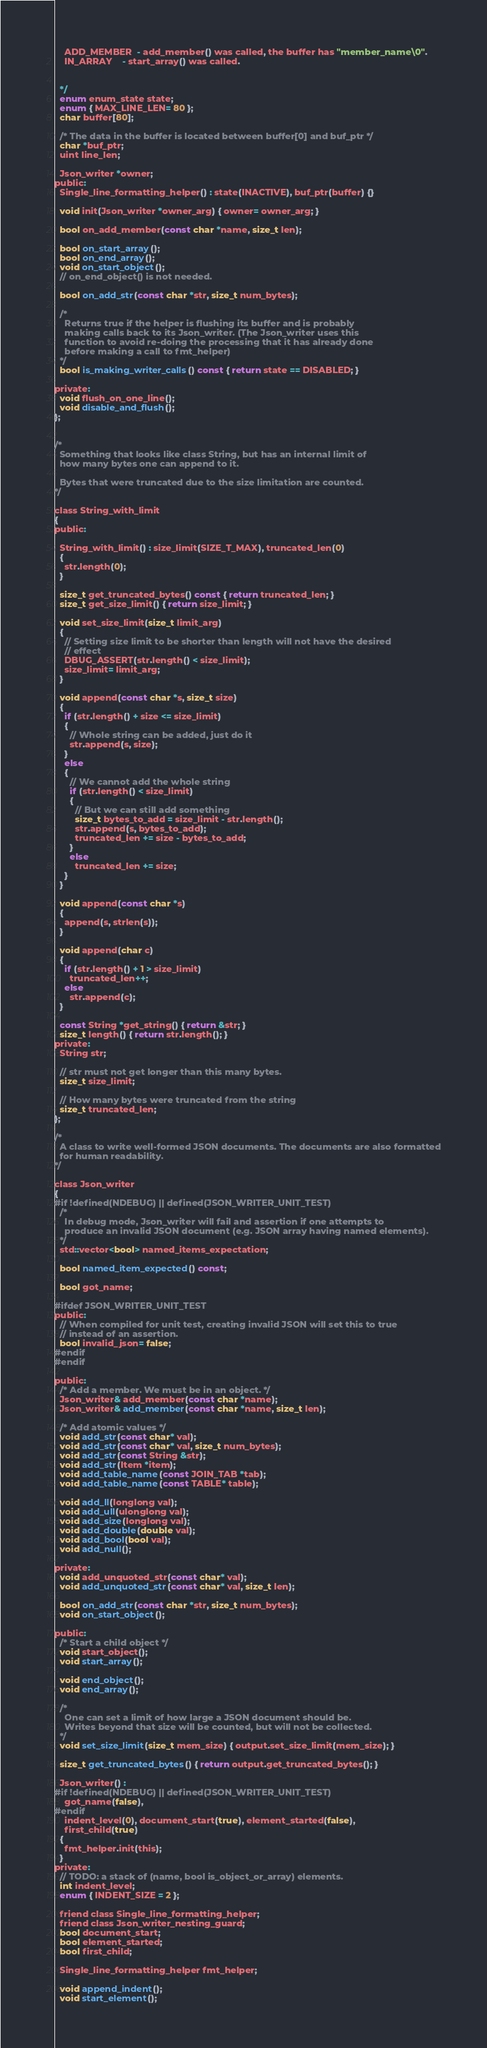<code> <loc_0><loc_0><loc_500><loc_500><_C_>    ADD_MEMBER  - add_member() was called, the buffer has "member_name\0".
    IN_ARRAY    - start_array() was called.


  */
  enum enum_state state;
  enum { MAX_LINE_LEN= 80 };
  char buffer[80];

  /* The data in the buffer is located between buffer[0] and buf_ptr */
  char *buf_ptr;
  uint line_len;

  Json_writer *owner;
public:
  Single_line_formatting_helper() : state(INACTIVE), buf_ptr(buffer) {}

  void init(Json_writer *owner_arg) { owner= owner_arg; }

  bool on_add_member(const char *name, size_t len);

  bool on_start_array();
  bool on_end_array();
  void on_start_object();
  // on_end_object() is not needed.

  bool on_add_str(const char *str, size_t num_bytes);

  /*
    Returns true if the helper is flushing its buffer and is probably
    making calls back to its Json_writer. (The Json_writer uses this
    function to avoid re-doing the processing that it has already done
    before making a call to fmt_helper)
  */
  bool is_making_writer_calls() const { return state == DISABLED; }

private:
  void flush_on_one_line();
  void disable_and_flush();
};


/*
  Something that looks like class String, but has an internal limit of
  how many bytes one can append to it.

  Bytes that were truncated due to the size limitation are counted.
*/

class String_with_limit
{
public:

  String_with_limit() : size_limit(SIZE_T_MAX), truncated_len(0)
  {
    str.length(0);
  }

  size_t get_truncated_bytes() const { return truncated_len; }
  size_t get_size_limit() { return size_limit; }

  void set_size_limit(size_t limit_arg)
  {
    // Setting size limit to be shorter than length will not have the desired
    // effect
    DBUG_ASSERT(str.length() < size_limit);
    size_limit= limit_arg;
  }

  void append(const char *s, size_t size)
  {
    if (str.length() + size <= size_limit)
    {
      // Whole string can be added, just do it
      str.append(s, size);
    }
    else
    {
      // We cannot add the whole string
      if (str.length() < size_limit)
      {
        // But we can still add something
        size_t bytes_to_add = size_limit - str.length();
        str.append(s, bytes_to_add);
        truncated_len += size - bytes_to_add;
      }
      else
        truncated_len += size;
    }
  }

  void append(const char *s)
  {
    append(s, strlen(s));
  }

  void append(char c)
  {
    if (str.length() + 1 > size_limit)
      truncated_len++;
    else
      str.append(c);
  }

  const String *get_string() { return &str; }
  size_t length() { return str.length(); }
private:
  String str;

  // str must not get longer than this many bytes.
  size_t size_limit;

  // How many bytes were truncated from the string
  size_t truncated_len;
};

/*
  A class to write well-formed JSON documents. The documents are also formatted
  for human readability.
*/

class Json_writer
{
#if !defined(NDEBUG) || defined(JSON_WRITER_UNIT_TEST)
  /*
    In debug mode, Json_writer will fail and assertion if one attempts to
    produce an invalid JSON document (e.g. JSON array having named elements).
  */
  std::vector<bool> named_items_expectation;

  bool named_item_expected() const;

  bool got_name;

#ifdef JSON_WRITER_UNIT_TEST
public:
  // When compiled for unit test, creating invalid JSON will set this to true
  // instead of an assertion.
  bool invalid_json= false;
#endif
#endif

public:
  /* Add a member. We must be in an object. */
  Json_writer& add_member(const char *name);
  Json_writer& add_member(const char *name, size_t len);
  
  /* Add atomic values */
  void add_str(const char* val);
  void add_str(const char* val, size_t num_bytes);
  void add_str(const String &str);
  void add_str(Item *item);
  void add_table_name(const JOIN_TAB *tab);
  void add_table_name(const TABLE* table);

  void add_ll(longlong val);
  void add_ull(ulonglong val);
  void add_size(longlong val);
  void add_double(double val);
  void add_bool(bool val);
  void add_null();

private:
  void add_unquoted_str(const char* val);
  void add_unquoted_str(const char* val, size_t len);

  bool on_add_str(const char *str, size_t num_bytes);
  void on_start_object();

public:
  /* Start a child object */
  void start_object();
  void start_array();

  void end_object();
  void end_array();
  
  /*
    One can set a limit of how large a JSON document should be.
    Writes beyond that size will be counted, but will not be collected.
  */
  void set_size_limit(size_t mem_size) { output.set_size_limit(mem_size); }

  size_t get_truncated_bytes() { return output.get_truncated_bytes(); }

  Json_writer() : 
#if !defined(NDEBUG) || defined(JSON_WRITER_UNIT_TEST)
    got_name(false),
#endif
    indent_level(0), document_start(true), element_started(false), 
    first_child(true)
  {
    fmt_helper.init(this);
  }
private:
  // TODO: a stack of (name, bool is_object_or_array) elements.
  int indent_level;
  enum { INDENT_SIZE = 2 };

  friend class Single_line_formatting_helper;
  friend class Json_writer_nesting_guard;
  bool document_start;
  bool element_started;
  bool first_child;

  Single_line_formatting_helper fmt_helper;

  void append_indent();
  void start_element();</code> 